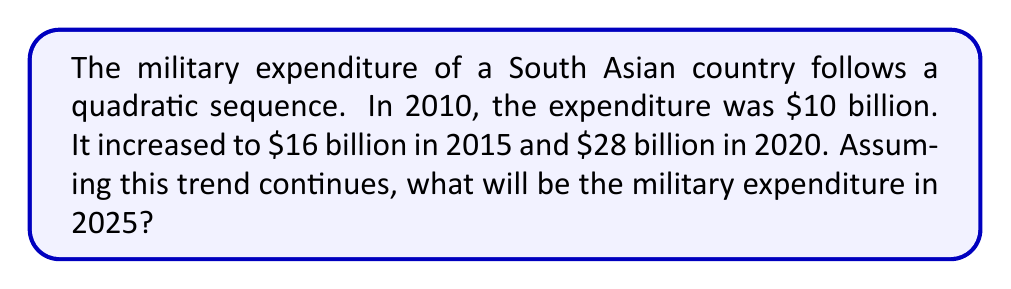Could you help me with this problem? Let's approach this step-by-step:

1) A quadratic sequence has the general form $an^2 + bn + c$, where $n$ is the term number.

2) We have three data points:
   2010 (n = 0): $10 billion
   2015 (n = 1): $16 billion
   2020 (n = 2): $28 billion

3) Let's set up three equations:
   $a(0)^2 + b(0) + c = 10$
   $a(1)^2 + b(1) + c = 16$
   $a(2)^2 + b(2) + c = 28$

4) Simplify:
   $c = 10$
   $a + b + 10 = 16$
   $4a + 2b + 10 = 28$

5) From the second equation: $a + b = 6$
   Substitute this into the third equation:
   $4a + 2(6-a) + 10 = 28$
   $4a + 12 - 2a + 10 = 28$
   $2a = 6$
   $a = 3$

6) If $a = 3$ and $a + b = 6$, then $b = 3$

7) Our quadratic sequence is therefore: $3n^2 + 3n + 10$

8) For 2025, n = 3:
   $3(3)^2 + 3(3) + 10 = 3(9) + 9 + 10 = 27 + 9 + 10 = 46$

Therefore, the military expenditure in 2025 will be $46 billion.
Answer: $46 billion 